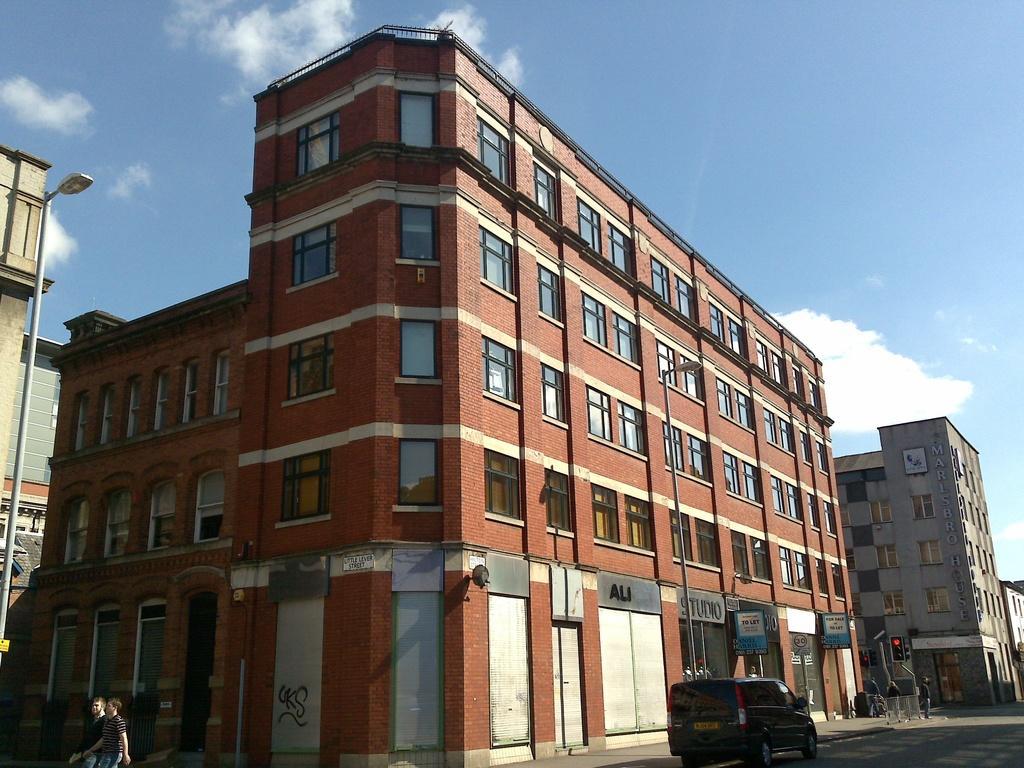Please provide a concise description of this image. In this picture, we can see two people are walking on the path and a vehicle on the road and on the path there are poles with light and traffic signals. Behind the vehicle, there are buildings and sky. 